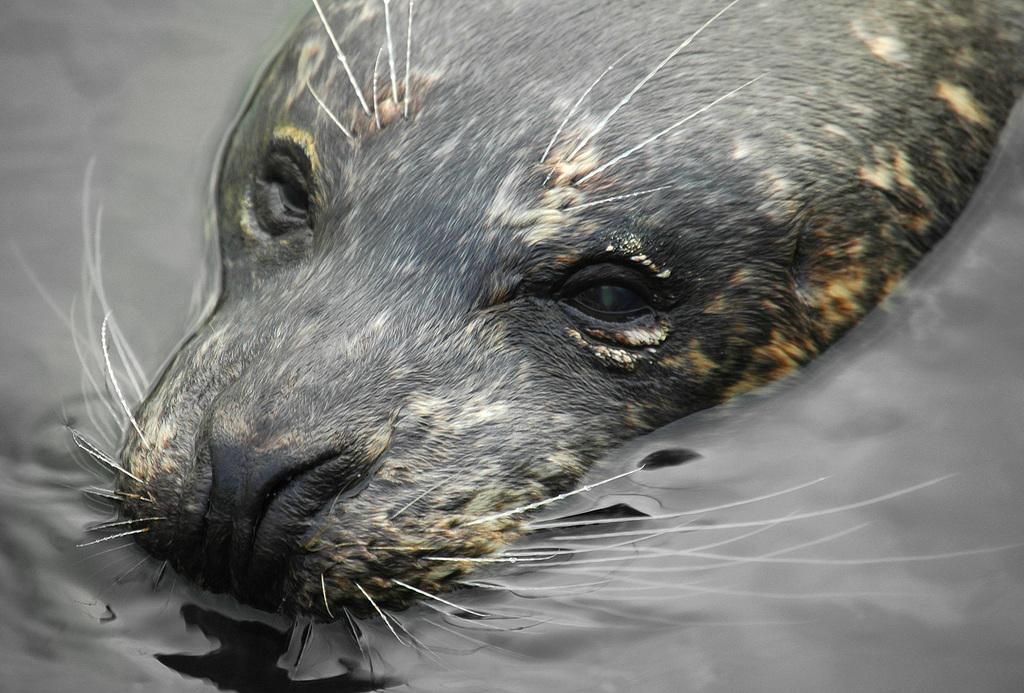What animal can be seen in the water in the image? There is a seal in the water in the image. What type of pie is being served to the seal in the image? There is no pie present in the image, and the seal is in the water, not being served any food. 